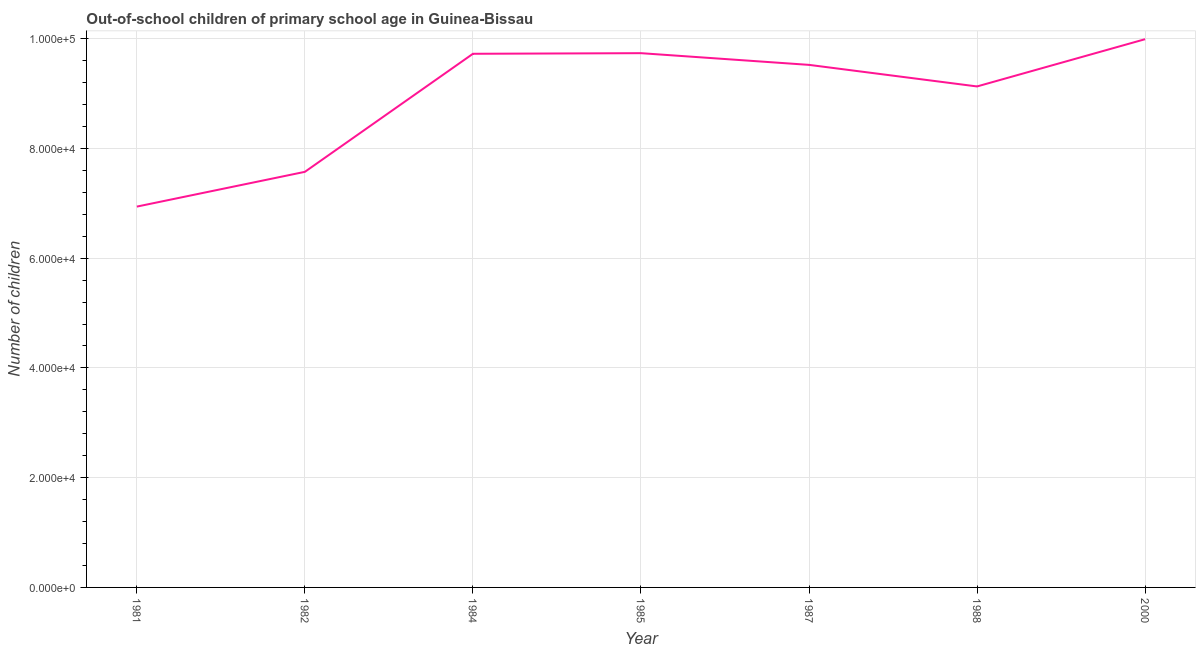What is the number of out-of-school children in 1982?
Offer a terse response. 7.57e+04. Across all years, what is the maximum number of out-of-school children?
Provide a succinct answer. 9.99e+04. Across all years, what is the minimum number of out-of-school children?
Offer a terse response. 6.94e+04. In which year was the number of out-of-school children minimum?
Ensure brevity in your answer.  1981. What is the sum of the number of out-of-school children?
Provide a short and direct response. 6.26e+05. What is the difference between the number of out-of-school children in 1982 and 1984?
Your answer should be compact. -2.15e+04. What is the average number of out-of-school children per year?
Make the answer very short. 8.95e+04. What is the median number of out-of-school children?
Provide a short and direct response. 9.52e+04. What is the ratio of the number of out-of-school children in 1981 to that in 1984?
Your response must be concise. 0.71. Is the number of out-of-school children in 1982 less than that in 1985?
Your response must be concise. Yes. Is the difference between the number of out-of-school children in 1984 and 2000 greater than the difference between any two years?
Your response must be concise. No. What is the difference between the highest and the second highest number of out-of-school children?
Your response must be concise. 2546. Is the sum of the number of out-of-school children in 1981 and 1987 greater than the maximum number of out-of-school children across all years?
Provide a succinct answer. Yes. What is the difference between the highest and the lowest number of out-of-school children?
Your answer should be compact. 3.05e+04. In how many years, is the number of out-of-school children greater than the average number of out-of-school children taken over all years?
Give a very brief answer. 5. Does the number of out-of-school children monotonically increase over the years?
Offer a terse response. No. How many years are there in the graph?
Your answer should be very brief. 7. Are the values on the major ticks of Y-axis written in scientific E-notation?
Offer a terse response. Yes. Does the graph contain any zero values?
Provide a short and direct response. No. What is the title of the graph?
Offer a very short reply. Out-of-school children of primary school age in Guinea-Bissau. What is the label or title of the Y-axis?
Keep it short and to the point. Number of children. What is the Number of children in 1981?
Give a very brief answer. 6.94e+04. What is the Number of children of 1982?
Provide a succinct answer. 7.57e+04. What is the Number of children of 1984?
Make the answer very short. 9.72e+04. What is the Number of children in 1985?
Provide a succinct answer. 9.74e+04. What is the Number of children in 1987?
Ensure brevity in your answer.  9.52e+04. What is the Number of children of 1988?
Offer a terse response. 9.13e+04. What is the Number of children in 2000?
Give a very brief answer. 9.99e+04. What is the difference between the Number of children in 1981 and 1982?
Your answer should be very brief. -6334. What is the difference between the Number of children in 1981 and 1984?
Ensure brevity in your answer.  -2.78e+04. What is the difference between the Number of children in 1981 and 1985?
Your answer should be compact. -2.80e+04. What is the difference between the Number of children in 1981 and 1987?
Provide a short and direct response. -2.58e+04. What is the difference between the Number of children in 1981 and 1988?
Ensure brevity in your answer.  -2.19e+04. What is the difference between the Number of children in 1981 and 2000?
Keep it short and to the point. -3.05e+04. What is the difference between the Number of children in 1982 and 1984?
Make the answer very short. -2.15e+04. What is the difference between the Number of children in 1982 and 1985?
Keep it short and to the point. -2.16e+04. What is the difference between the Number of children in 1982 and 1987?
Ensure brevity in your answer.  -1.95e+04. What is the difference between the Number of children in 1982 and 1988?
Provide a short and direct response. -1.56e+04. What is the difference between the Number of children in 1982 and 2000?
Make the answer very short. -2.42e+04. What is the difference between the Number of children in 1984 and 1985?
Provide a short and direct response. -113. What is the difference between the Number of children in 1984 and 1987?
Offer a very short reply. 2020. What is the difference between the Number of children in 1984 and 1988?
Provide a succinct answer. 5952. What is the difference between the Number of children in 1984 and 2000?
Keep it short and to the point. -2659. What is the difference between the Number of children in 1985 and 1987?
Your answer should be compact. 2133. What is the difference between the Number of children in 1985 and 1988?
Your answer should be very brief. 6065. What is the difference between the Number of children in 1985 and 2000?
Keep it short and to the point. -2546. What is the difference between the Number of children in 1987 and 1988?
Ensure brevity in your answer.  3932. What is the difference between the Number of children in 1987 and 2000?
Keep it short and to the point. -4679. What is the difference between the Number of children in 1988 and 2000?
Provide a short and direct response. -8611. What is the ratio of the Number of children in 1981 to that in 1982?
Offer a very short reply. 0.92. What is the ratio of the Number of children in 1981 to that in 1984?
Provide a short and direct response. 0.71. What is the ratio of the Number of children in 1981 to that in 1985?
Provide a succinct answer. 0.71. What is the ratio of the Number of children in 1981 to that in 1987?
Give a very brief answer. 0.73. What is the ratio of the Number of children in 1981 to that in 1988?
Ensure brevity in your answer.  0.76. What is the ratio of the Number of children in 1981 to that in 2000?
Offer a terse response. 0.69. What is the ratio of the Number of children in 1982 to that in 1984?
Keep it short and to the point. 0.78. What is the ratio of the Number of children in 1982 to that in 1985?
Your answer should be very brief. 0.78. What is the ratio of the Number of children in 1982 to that in 1987?
Your answer should be very brief. 0.8. What is the ratio of the Number of children in 1982 to that in 1988?
Your answer should be compact. 0.83. What is the ratio of the Number of children in 1982 to that in 2000?
Offer a terse response. 0.76. What is the ratio of the Number of children in 1984 to that in 1988?
Provide a short and direct response. 1.06. What is the ratio of the Number of children in 1984 to that in 2000?
Your answer should be very brief. 0.97. What is the ratio of the Number of children in 1985 to that in 1987?
Your answer should be compact. 1.02. What is the ratio of the Number of children in 1985 to that in 1988?
Your answer should be compact. 1.07. What is the ratio of the Number of children in 1985 to that in 2000?
Keep it short and to the point. 0.97. What is the ratio of the Number of children in 1987 to that in 1988?
Keep it short and to the point. 1.04. What is the ratio of the Number of children in 1987 to that in 2000?
Your answer should be compact. 0.95. What is the ratio of the Number of children in 1988 to that in 2000?
Provide a short and direct response. 0.91. 